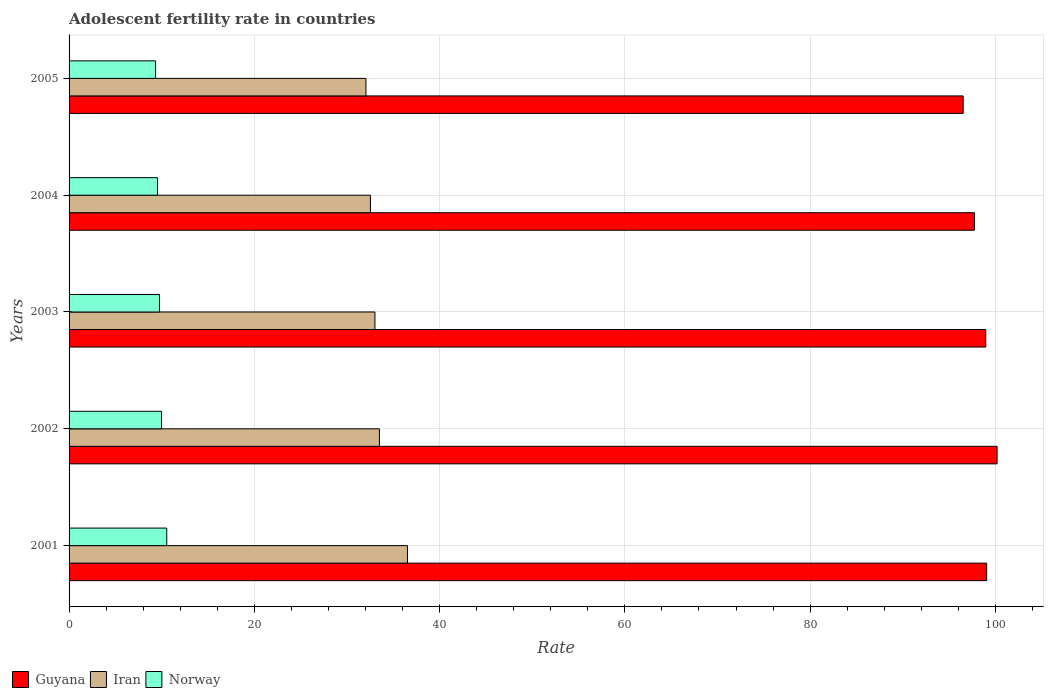How many different coloured bars are there?
Provide a short and direct response. 3. Are the number of bars per tick equal to the number of legend labels?
Keep it short and to the point. Yes. Are the number of bars on each tick of the Y-axis equal?
Your answer should be very brief. Yes. What is the label of the 3rd group of bars from the top?
Your answer should be compact. 2003. What is the adolescent fertility rate in Norway in 2001?
Offer a very short reply. 10.55. Across all years, what is the maximum adolescent fertility rate in Iran?
Make the answer very short. 36.53. Across all years, what is the minimum adolescent fertility rate in Iran?
Your answer should be compact. 32.05. In which year was the adolescent fertility rate in Guyana minimum?
Keep it short and to the point. 2005. What is the total adolescent fertility rate in Guyana in the graph?
Your answer should be compact. 492.45. What is the difference between the adolescent fertility rate in Norway in 2001 and that in 2004?
Your answer should be compact. 0.99. What is the difference between the adolescent fertility rate in Iran in 2003 and the adolescent fertility rate in Guyana in 2002?
Your answer should be very brief. -67.16. What is the average adolescent fertility rate in Norway per year?
Your answer should be compact. 9.84. In the year 2002, what is the difference between the adolescent fertility rate in Guyana and adolescent fertility rate in Norway?
Keep it short and to the point. 90.2. What is the ratio of the adolescent fertility rate in Norway in 2002 to that in 2003?
Provide a short and direct response. 1.02. Is the difference between the adolescent fertility rate in Guyana in 2003 and 2004 greater than the difference between the adolescent fertility rate in Norway in 2003 and 2004?
Make the answer very short. Yes. What is the difference between the highest and the second highest adolescent fertility rate in Guyana?
Your answer should be compact. 1.13. What is the difference between the highest and the lowest adolescent fertility rate in Norway?
Your answer should be very brief. 1.21. In how many years, is the adolescent fertility rate in Norway greater than the average adolescent fertility rate in Norway taken over all years?
Offer a terse response. 2. Is the sum of the adolescent fertility rate in Norway in 2001 and 2005 greater than the maximum adolescent fertility rate in Iran across all years?
Provide a short and direct response. No. What does the 3rd bar from the top in 2002 represents?
Make the answer very short. Guyana. What does the 3rd bar from the bottom in 2002 represents?
Your answer should be very brief. Norway. Is it the case that in every year, the sum of the adolescent fertility rate in Guyana and adolescent fertility rate in Norway is greater than the adolescent fertility rate in Iran?
Make the answer very short. Yes. How many legend labels are there?
Provide a short and direct response. 3. What is the title of the graph?
Offer a very short reply. Adolescent fertility rate in countries. Does "Bahamas" appear as one of the legend labels in the graph?
Provide a short and direct response. No. What is the label or title of the X-axis?
Ensure brevity in your answer.  Rate. What is the Rate of Guyana in 2001?
Ensure brevity in your answer.  99.05. What is the Rate of Iran in 2001?
Give a very brief answer. 36.53. What is the Rate of Norway in 2001?
Give a very brief answer. 10.55. What is the Rate of Guyana in 2002?
Provide a succinct answer. 100.18. What is the Rate in Iran in 2002?
Ensure brevity in your answer.  33.5. What is the Rate in Norway in 2002?
Give a very brief answer. 9.98. What is the Rate in Guyana in 2003?
Your answer should be very brief. 98.96. What is the Rate of Iran in 2003?
Provide a short and direct response. 33.02. What is the Rate in Norway in 2003?
Offer a very short reply. 9.76. What is the Rate of Guyana in 2004?
Offer a terse response. 97.74. What is the Rate of Iran in 2004?
Your answer should be very brief. 32.53. What is the Rate of Norway in 2004?
Offer a very short reply. 9.55. What is the Rate in Guyana in 2005?
Make the answer very short. 96.52. What is the Rate of Iran in 2005?
Provide a succinct answer. 32.05. What is the Rate in Norway in 2005?
Make the answer very short. 9.34. Across all years, what is the maximum Rate of Guyana?
Keep it short and to the point. 100.18. Across all years, what is the maximum Rate of Iran?
Offer a very short reply. 36.53. Across all years, what is the maximum Rate of Norway?
Your answer should be very brief. 10.55. Across all years, what is the minimum Rate of Guyana?
Give a very brief answer. 96.52. Across all years, what is the minimum Rate in Iran?
Your answer should be compact. 32.05. Across all years, what is the minimum Rate of Norway?
Provide a succinct answer. 9.34. What is the total Rate of Guyana in the graph?
Ensure brevity in your answer.  492.45. What is the total Rate in Iran in the graph?
Offer a terse response. 167.63. What is the total Rate of Norway in the graph?
Give a very brief answer. 49.18. What is the difference between the Rate in Guyana in 2001 and that in 2002?
Provide a short and direct response. -1.13. What is the difference between the Rate of Iran in 2001 and that in 2002?
Your response must be concise. 3.03. What is the difference between the Rate of Norway in 2001 and that in 2002?
Provide a succinct answer. 0.57. What is the difference between the Rate in Guyana in 2001 and that in 2003?
Your response must be concise. 0.1. What is the difference between the Rate of Iran in 2001 and that in 2003?
Provide a succinct answer. 3.51. What is the difference between the Rate of Norway in 2001 and that in 2003?
Your answer should be compact. 0.78. What is the difference between the Rate of Guyana in 2001 and that in 2004?
Give a very brief answer. 1.32. What is the difference between the Rate in Iran in 2001 and that in 2004?
Make the answer very short. 4. What is the difference between the Rate of Guyana in 2001 and that in 2005?
Your answer should be compact. 2.54. What is the difference between the Rate in Iran in 2001 and that in 2005?
Give a very brief answer. 4.48. What is the difference between the Rate of Norway in 2001 and that in 2005?
Your answer should be very brief. 1.21. What is the difference between the Rate in Guyana in 2002 and that in 2003?
Give a very brief answer. 1.22. What is the difference between the Rate of Iran in 2002 and that in 2003?
Your answer should be very brief. 0.48. What is the difference between the Rate of Norway in 2002 and that in 2003?
Your answer should be very brief. 0.21. What is the difference between the Rate of Guyana in 2002 and that in 2004?
Make the answer very short. 2.44. What is the difference between the Rate of Iran in 2002 and that in 2004?
Give a very brief answer. 0.97. What is the difference between the Rate in Norway in 2002 and that in 2004?
Offer a very short reply. 0.43. What is the difference between the Rate of Guyana in 2002 and that in 2005?
Offer a very short reply. 3.66. What is the difference between the Rate in Iran in 2002 and that in 2005?
Your response must be concise. 1.45. What is the difference between the Rate in Norway in 2002 and that in 2005?
Your answer should be very brief. 0.64. What is the difference between the Rate of Guyana in 2003 and that in 2004?
Offer a terse response. 1.22. What is the difference between the Rate of Iran in 2003 and that in 2004?
Provide a short and direct response. 0.48. What is the difference between the Rate in Norway in 2003 and that in 2004?
Offer a terse response. 0.21. What is the difference between the Rate of Guyana in 2003 and that in 2005?
Your response must be concise. 2.44. What is the difference between the Rate of Iran in 2003 and that in 2005?
Offer a very short reply. 0.97. What is the difference between the Rate of Norway in 2003 and that in 2005?
Keep it short and to the point. 0.43. What is the difference between the Rate in Guyana in 2004 and that in 2005?
Your response must be concise. 1.22. What is the difference between the Rate of Iran in 2004 and that in 2005?
Provide a short and direct response. 0.48. What is the difference between the Rate of Norway in 2004 and that in 2005?
Your answer should be very brief. 0.21. What is the difference between the Rate in Guyana in 2001 and the Rate in Iran in 2002?
Provide a succinct answer. 65.55. What is the difference between the Rate of Guyana in 2001 and the Rate of Norway in 2002?
Provide a short and direct response. 89.08. What is the difference between the Rate of Iran in 2001 and the Rate of Norway in 2002?
Give a very brief answer. 26.55. What is the difference between the Rate of Guyana in 2001 and the Rate of Iran in 2003?
Offer a very short reply. 66.04. What is the difference between the Rate of Guyana in 2001 and the Rate of Norway in 2003?
Keep it short and to the point. 89.29. What is the difference between the Rate of Iran in 2001 and the Rate of Norway in 2003?
Make the answer very short. 26.77. What is the difference between the Rate in Guyana in 2001 and the Rate in Iran in 2004?
Provide a short and direct response. 66.52. What is the difference between the Rate of Guyana in 2001 and the Rate of Norway in 2004?
Provide a short and direct response. 89.5. What is the difference between the Rate of Iran in 2001 and the Rate of Norway in 2004?
Make the answer very short. 26.98. What is the difference between the Rate in Guyana in 2001 and the Rate in Iran in 2005?
Provide a short and direct response. 67.01. What is the difference between the Rate of Guyana in 2001 and the Rate of Norway in 2005?
Provide a short and direct response. 89.72. What is the difference between the Rate of Iran in 2001 and the Rate of Norway in 2005?
Your answer should be compact. 27.19. What is the difference between the Rate of Guyana in 2002 and the Rate of Iran in 2003?
Your answer should be compact. 67.16. What is the difference between the Rate of Guyana in 2002 and the Rate of Norway in 2003?
Ensure brevity in your answer.  90.42. What is the difference between the Rate of Iran in 2002 and the Rate of Norway in 2003?
Provide a short and direct response. 23.74. What is the difference between the Rate in Guyana in 2002 and the Rate in Iran in 2004?
Your response must be concise. 67.65. What is the difference between the Rate of Guyana in 2002 and the Rate of Norway in 2004?
Make the answer very short. 90.63. What is the difference between the Rate in Iran in 2002 and the Rate in Norway in 2004?
Provide a short and direct response. 23.95. What is the difference between the Rate of Guyana in 2002 and the Rate of Iran in 2005?
Offer a terse response. 68.13. What is the difference between the Rate in Guyana in 2002 and the Rate in Norway in 2005?
Offer a very short reply. 90.84. What is the difference between the Rate of Iran in 2002 and the Rate of Norway in 2005?
Provide a succinct answer. 24.16. What is the difference between the Rate of Guyana in 2003 and the Rate of Iran in 2004?
Make the answer very short. 66.43. What is the difference between the Rate in Guyana in 2003 and the Rate in Norway in 2004?
Make the answer very short. 89.41. What is the difference between the Rate in Iran in 2003 and the Rate in Norway in 2004?
Provide a succinct answer. 23.47. What is the difference between the Rate in Guyana in 2003 and the Rate in Iran in 2005?
Give a very brief answer. 66.91. What is the difference between the Rate of Guyana in 2003 and the Rate of Norway in 2005?
Provide a short and direct response. 89.62. What is the difference between the Rate in Iran in 2003 and the Rate in Norway in 2005?
Keep it short and to the point. 23.68. What is the difference between the Rate of Guyana in 2004 and the Rate of Iran in 2005?
Provide a short and direct response. 65.69. What is the difference between the Rate in Guyana in 2004 and the Rate in Norway in 2005?
Give a very brief answer. 88.4. What is the difference between the Rate of Iran in 2004 and the Rate of Norway in 2005?
Provide a short and direct response. 23.19. What is the average Rate in Guyana per year?
Provide a succinct answer. 98.49. What is the average Rate in Iran per year?
Provide a succinct answer. 33.53. What is the average Rate in Norway per year?
Keep it short and to the point. 9.84. In the year 2001, what is the difference between the Rate of Guyana and Rate of Iran?
Your response must be concise. 62.52. In the year 2001, what is the difference between the Rate of Guyana and Rate of Norway?
Your response must be concise. 88.51. In the year 2001, what is the difference between the Rate of Iran and Rate of Norway?
Offer a very short reply. 25.98. In the year 2002, what is the difference between the Rate in Guyana and Rate in Iran?
Keep it short and to the point. 66.68. In the year 2002, what is the difference between the Rate in Guyana and Rate in Norway?
Provide a succinct answer. 90.2. In the year 2002, what is the difference between the Rate in Iran and Rate in Norway?
Provide a short and direct response. 23.53. In the year 2003, what is the difference between the Rate in Guyana and Rate in Iran?
Ensure brevity in your answer.  65.94. In the year 2003, what is the difference between the Rate in Guyana and Rate in Norway?
Your answer should be compact. 89.19. In the year 2003, what is the difference between the Rate of Iran and Rate of Norway?
Offer a terse response. 23.25. In the year 2004, what is the difference between the Rate in Guyana and Rate in Iran?
Your response must be concise. 65.2. In the year 2004, what is the difference between the Rate of Guyana and Rate of Norway?
Your response must be concise. 88.19. In the year 2004, what is the difference between the Rate in Iran and Rate in Norway?
Give a very brief answer. 22.98. In the year 2005, what is the difference between the Rate in Guyana and Rate in Iran?
Your response must be concise. 64.47. In the year 2005, what is the difference between the Rate of Guyana and Rate of Norway?
Offer a terse response. 87.18. In the year 2005, what is the difference between the Rate in Iran and Rate in Norway?
Offer a terse response. 22.71. What is the ratio of the Rate of Iran in 2001 to that in 2002?
Your response must be concise. 1.09. What is the ratio of the Rate in Norway in 2001 to that in 2002?
Make the answer very short. 1.06. What is the ratio of the Rate of Guyana in 2001 to that in 2003?
Keep it short and to the point. 1. What is the ratio of the Rate in Iran in 2001 to that in 2003?
Give a very brief answer. 1.11. What is the ratio of the Rate of Norway in 2001 to that in 2003?
Give a very brief answer. 1.08. What is the ratio of the Rate of Guyana in 2001 to that in 2004?
Your answer should be very brief. 1.01. What is the ratio of the Rate of Iran in 2001 to that in 2004?
Your answer should be compact. 1.12. What is the ratio of the Rate in Norway in 2001 to that in 2004?
Your answer should be compact. 1.1. What is the ratio of the Rate of Guyana in 2001 to that in 2005?
Give a very brief answer. 1.03. What is the ratio of the Rate of Iran in 2001 to that in 2005?
Make the answer very short. 1.14. What is the ratio of the Rate in Norway in 2001 to that in 2005?
Your answer should be very brief. 1.13. What is the ratio of the Rate of Guyana in 2002 to that in 2003?
Make the answer very short. 1.01. What is the ratio of the Rate in Iran in 2002 to that in 2003?
Your answer should be very brief. 1.01. What is the ratio of the Rate of Norway in 2002 to that in 2003?
Your answer should be compact. 1.02. What is the ratio of the Rate in Guyana in 2002 to that in 2004?
Give a very brief answer. 1.02. What is the ratio of the Rate in Iran in 2002 to that in 2004?
Your answer should be very brief. 1.03. What is the ratio of the Rate in Norway in 2002 to that in 2004?
Provide a succinct answer. 1.04. What is the ratio of the Rate of Guyana in 2002 to that in 2005?
Your answer should be compact. 1.04. What is the ratio of the Rate in Iran in 2002 to that in 2005?
Offer a very short reply. 1.05. What is the ratio of the Rate in Norway in 2002 to that in 2005?
Make the answer very short. 1.07. What is the ratio of the Rate in Guyana in 2003 to that in 2004?
Your response must be concise. 1.01. What is the ratio of the Rate in Iran in 2003 to that in 2004?
Make the answer very short. 1.01. What is the ratio of the Rate in Norway in 2003 to that in 2004?
Offer a very short reply. 1.02. What is the ratio of the Rate in Guyana in 2003 to that in 2005?
Provide a succinct answer. 1.03. What is the ratio of the Rate in Iran in 2003 to that in 2005?
Keep it short and to the point. 1.03. What is the ratio of the Rate of Norway in 2003 to that in 2005?
Your answer should be very brief. 1.05. What is the ratio of the Rate of Guyana in 2004 to that in 2005?
Provide a short and direct response. 1.01. What is the ratio of the Rate of Iran in 2004 to that in 2005?
Your answer should be very brief. 1.02. What is the ratio of the Rate of Norway in 2004 to that in 2005?
Ensure brevity in your answer.  1.02. What is the difference between the highest and the second highest Rate in Guyana?
Provide a short and direct response. 1.13. What is the difference between the highest and the second highest Rate of Iran?
Provide a succinct answer. 3.03. What is the difference between the highest and the second highest Rate in Norway?
Your answer should be compact. 0.57. What is the difference between the highest and the lowest Rate of Guyana?
Give a very brief answer. 3.66. What is the difference between the highest and the lowest Rate in Iran?
Your response must be concise. 4.48. What is the difference between the highest and the lowest Rate in Norway?
Ensure brevity in your answer.  1.21. 